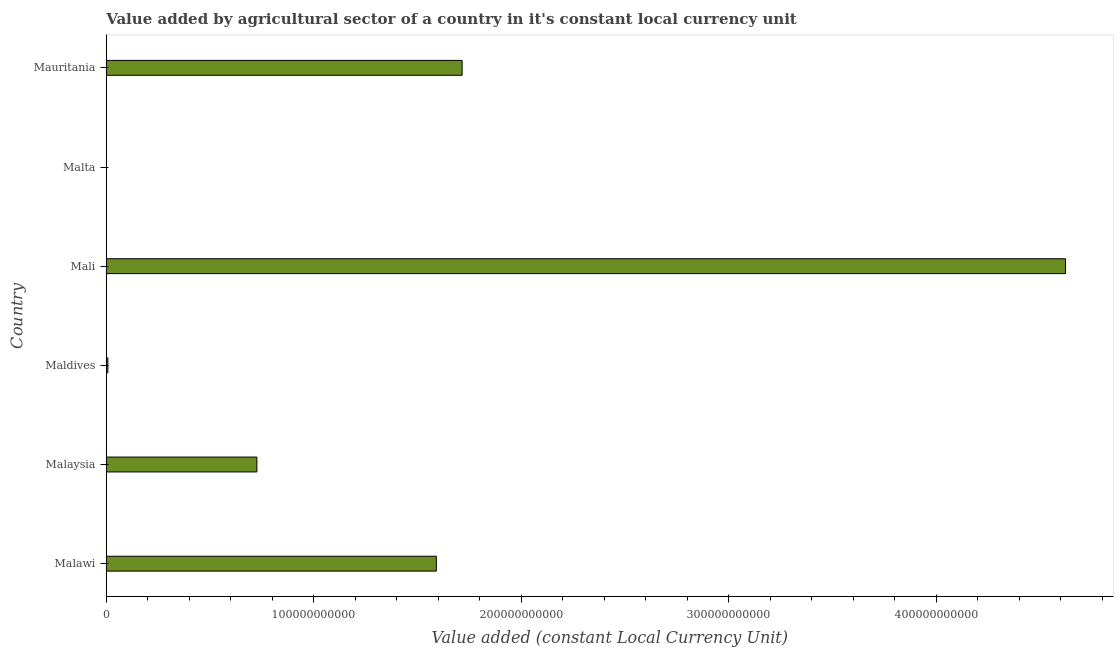Does the graph contain any zero values?
Keep it short and to the point. No. Does the graph contain grids?
Your answer should be very brief. No. What is the title of the graph?
Your answer should be compact. Value added by agricultural sector of a country in it's constant local currency unit. What is the label or title of the X-axis?
Keep it short and to the point. Value added (constant Local Currency Unit). What is the label or title of the Y-axis?
Give a very brief answer. Country. What is the value added by agriculture sector in Malta?
Your answer should be very brief. 1.10e+08. Across all countries, what is the maximum value added by agriculture sector?
Your response must be concise. 4.62e+11. Across all countries, what is the minimum value added by agriculture sector?
Offer a very short reply. 1.10e+08. In which country was the value added by agriculture sector maximum?
Give a very brief answer. Mali. In which country was the value added by agriculture sector minimum?
Ensure brevity in your answer.  Malta. What is the sum of the value added by agriculture sector?
Keep it short and to the point. 8.67e+11. What is the difference between the value added by agriculture sector in Maldives and Mali?
Provide a succinct answer. -4.62e+11. What is the average value added by agriculture sector per country?
Provide a short and direct response. 1.44e+11. What is the median value added by agriculture sector?
Ensure brevity in your answer.  1.16e+11. In how many countries, is the value added by agriculture sector greater than 300000000000 LCU?
Ensure brevity in your answer.  1. What is the ratio of the value added by agriculture sector in Maldives to that in Malta?
Offer a very short reply. 7.18. Is the difference between the value added by agriculture sector in Malaysia and Mali greater than the difference between any two countries?
Your answer should be compact. No. What is the difference between the highest and the second highest value added by agriculture sector?
Offer a very short reply. 2.91e+11. What is the difference between the highest and the lowest value added by agriculture sector?
Make the answer very short. 4.62e+11. In how many countries, is the value added by agriculture sector greater than the average value added by agriculture sector taken over all countries?
Your response must be concise. 3. How many bars are there?
Your response must be concise. 6. What is the difference between two consecutive major ticks on the X-axis?
Ensure brevity in your answer.  1.00e+11. What is the Value added (constant Local Currency Unit) in Malawi?
Provide a short and direct response. 1.59e+11. What is the Value added (constant Local Currency Unit) in Malaysia?
Offer a very short reply. 7.26e+1. What is the Value added (constant Local Currency Unit) of Maldives?
Make the answer very short. 7.86e+08. What is the Value added (constant Local Currency Unit) in Mali?
Your response must be concise. 4.62e+11. What is the Value added (constant Local Currency Unit) of Malta?
Ensure brevity in your answer.  1.10e+08. What is the Value added (constant Local Currency Unit) of Mauritania?
Provide a short and direct response. 1.72e+11. What is the difference between the Value added (constant Local Currency Unit) in Malawi and Malaysia?
Your answer should be very brief. 8.65e+1. What is the difference between the Value added (constant Local Currency Unit) in Malawi and Maldives?
Your answer should be compact. 1.58e+11. What is the difference between the Value added (constant Local Currency Unit) in Malawi and Mali?
Ensure brevity in your answer.  -3.03e+11. What is the difference between the Value added (constant Local Currency Unit) in Malawi and Malta?
Ensure brevity in your answer.  1.59e+11. What is the difference between the Value added (constant Local Currency Unit) in Malawi and Mauritania?
Your answer should be compact. -1.24e+1. What is the difference between the Value added (constant Local Currency Unit) in Malaysia and Maldives?
Offer a terse response. 7.18e+1. What is the difference between the Value added (constant Local Currency Unit) in Malaysia and Mali?
Offer a very short reply. -3.90e+11. What is the difference between the Value added (constant Local Currency Unit) in Malaysia and Malta?
Your answer should be very brief. 7.25e+1. What is the difference between the Value added (constant Local Currency Unit) in Malaysia and Mauritania?
Keep it short and to the point. -9.89e+1. What is the difference between the Value added (constant Local Currency Unit) in Maldives and Mali?
Provide a short and direct response. -4.62e+11. What is the difference between the Value added (constant Local Currency Unit) in Maldives and Malta?
Your answer should be very brief. 6.77e+08. What is the difference between the Value added (constant Local Currency Unit) in Maldives and Mauritania?
Provide a succinct answer. -1.71e+11. What is the difference between the Value added (constant Local Currency Unit) in Mali and Malta?
Your response must be concise. 4.62e+11. What is the difference between the Value added (constant Local Currency Unit) in Mali and Mauritania?
Your answer should be very brief. 2.91e+11. What is the difference between the Value added (constant Local Currency Unit) in Malta and Mauritania?
Give a very brief answer. -1.71e+11. What is the ratio of the Value added (constant Local Currency Unit) in Malawi to that in Malaysia?
Provide a succinct answer. 2.19. What is the ratio of the Value added (constant Local Currency Unit) in Malawi to that in Maldives?
Ensure brevity in your answer.  202.4. What is the ratio of the Value added (constant Local Currency Unit) in Malawi to that in Mali?
Your answer should be very brief. 0.34. What is the ratio of the Value added (constant Local Currency Unit) in Malawi to that in Malta?
Your answer should be very brief. 1453.14. What is the ratio of the Value added (constant Local Currency Unit) in Malawi to that in Mauritania?
Offer a very short reply. 0.93. What is the ratio of the Value added (constant Local Currency Unit) in Malaysia to that in Maldives?
Give a very brief answer. 92.36. What is the ratio of the Value added (constant Local Currency Unit) in Malaysia to that in Mali?
Your response must be concise. 0.16. What is the ratio of the Value added (constant Local Currency Unit) in Malaysia to that in Malta?
Offer a terse response. 663.1. What is the ratio of the Value added (constant Local Currency Unit) in Malaysia to that in Mauritania?
Give a very brief answer. 0.42. What is the ratio of the Value added (constant Local Currency Unit) in Maldives to that in Mali?
Give a very brief answer. 0. What is the ratio of the Value added (constant Local Currency Unit) in Maldives to that in Malta?
Ensure brevity in your answer.  7.18. What is the ratio of the Value added (constant Local Currency Unit) in Maldives to that in Mauritania?
Give a very brief answer. 0.01. What is the ratio of the Value added (constant Local Currency Unit) in Mali to that in Malta?
Ensure brevity in your answer.  4222.77. What is the ratio of the Value added (constant Local Currency Unit) in Mali to that in Mauritania?
Give a very brief answer. 2.7. 